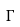Convert formula to latex. <formula><loc_0><loc_0><loc_500><loc_500>\Gamma</formula> 